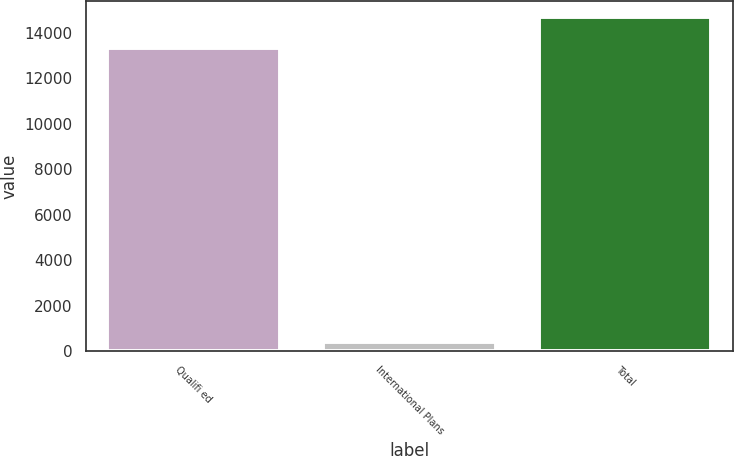Convert chart to OTSL. <chart><loc_0><loc_0><loc_500><loc_500><bar_chart><fcel>Qualifi ed<fcel>International Plans<fcel>Total<nl><fcel>13311<fcel>384<fcel>14676.7<nl></chart> 